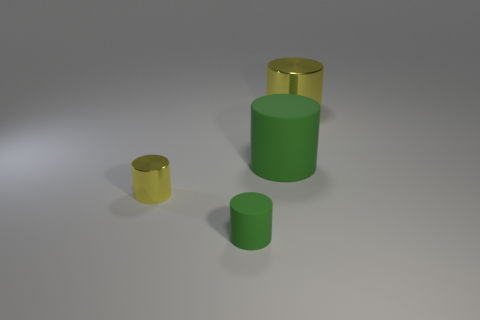There is a tiny metallic thing that is the same color as the large shiny cylinder; what shape is it?
Offer a terse response. Cylinder. There is a cylinder that is on the right side of the small matte object and in front of the large metal cylinder; what is its size?
Make the answer very short. Large. There is a cylinder that is the same color as the tiny rubber thing; what is its size?
Keep it short and to the point. Large. How many things are small matte objects or yellow shiny objects on the left side of the tiny green matte cylinder?
Provide a short and direct response. 2. What number of things are cylinders or metallic cylinders?
Provide a succinct answer. 4. Are there any tiny yellow metallic cylinders?
Offer a very short reply. Yes. Are the cylinder that is to the right of the big green cylinder and the tiny green object made of the same material?
Your answer should be compact. No. Are there any tiny gray objects of the same shape as the large yellow metal object?
Provide a succinct answer. No. Is the number of tiny yellow objects on the right side of the tiny green thing the same as the number of small gray spheres?
Provide a short and direct response. Yes. There is a yellow cylinder that is left of the small matte thing that is left of the large yellow cylinder; what is its material?
Provide a succinct answer. Metal. 